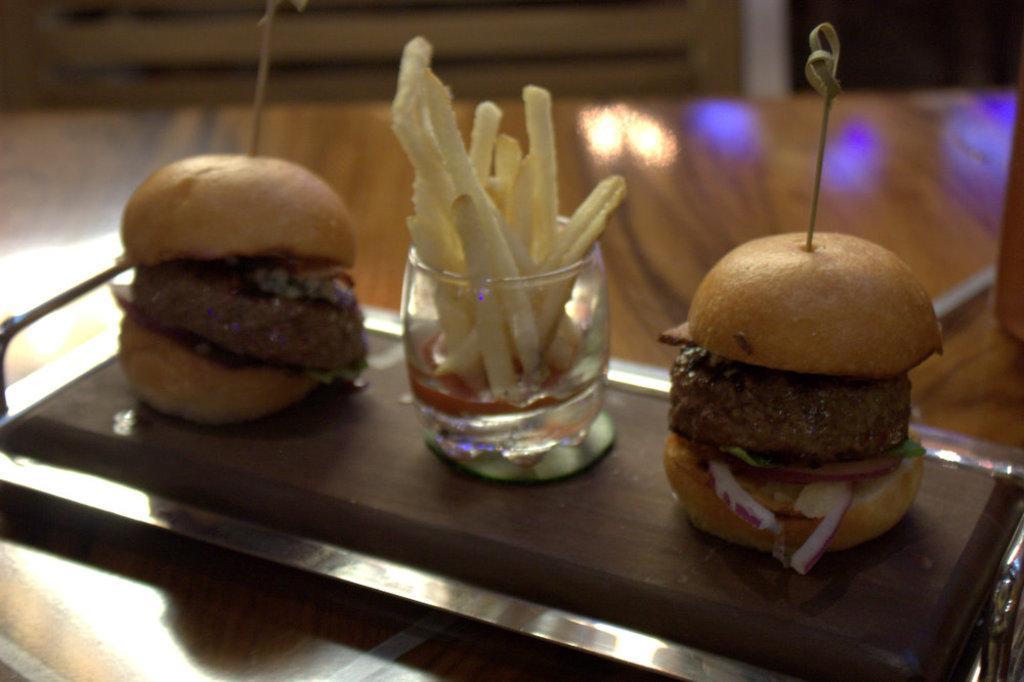How would you summarize this image in a sentence or two? In the center of the image there are food items in a tray. There is a glass with french fries in it. 